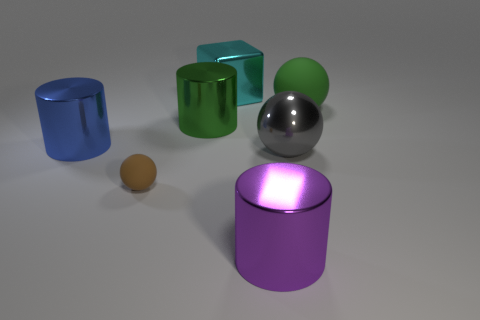What color is the cube that is the same material as the large purple cylinder? The cube that appears to be made of the same shiny, reflective material as the large purple cylinder is cyan in color. It's interesting to note that the material's reflective quality gives it a slightly varied appearance depending on the angle of view, emphasizing the sheen and depth of the cyan color. 